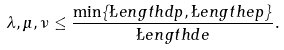Convert formula to latex. <formula><loc_0><loc_0><loc_500><loc_500>\lambda , \mu , \nu \leq \frac { \min \{ \L e n g t h { d p } , \L e n g t h { e p } \} } { \L e n g t h { d e } } .</formula> 